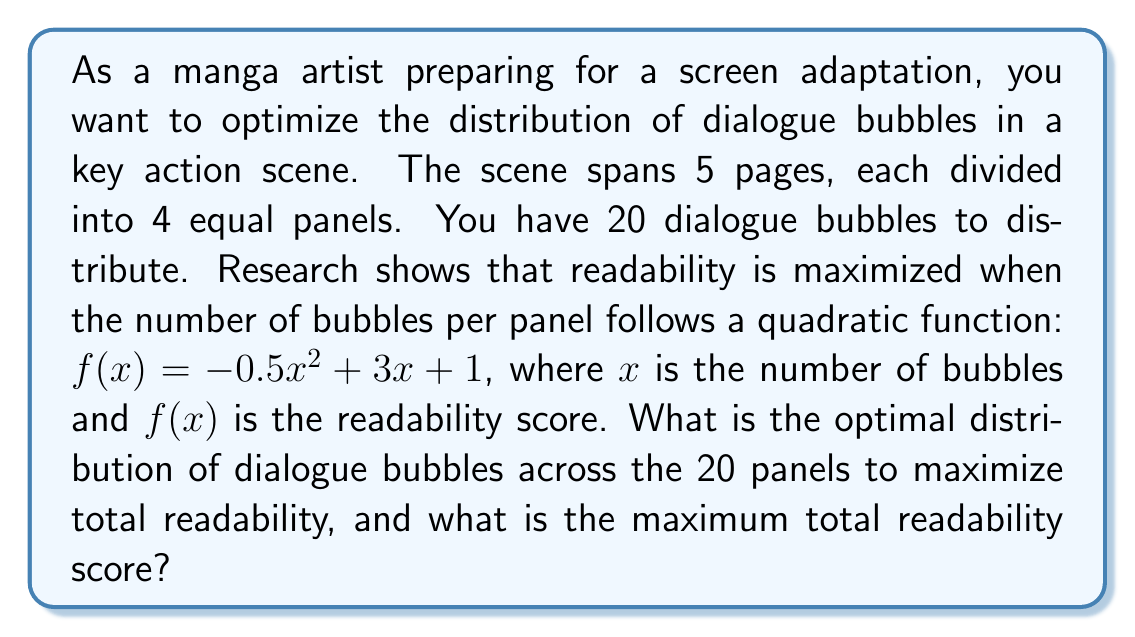Help me with this question. To solve this problem, we need to use integer programming techniques from operations research. Let's approach this step-by-step:

1) First, we need to set up our objective function. We want to maximize the total readability score across all panels:

   $\text{Maximize } \sum_{i=1}^{20} (-0.5x_i^2 + 3x_i + 1)$

   where $x_i$ is the number of bubbles in panel $i$.

2) Our constraints are:
   - The sum of all bubbles must equal 20: $\sum_{i=1}^{20} x_i = 20$
   - Each $x_i$ must be a non-negative integer

3) To find the optimal solution, we can use the method of Lagrange multipliers. However, due to the integer constraint, we need to round our results.

4) The Lagrangian function is:

   $L(x_1, ..., x_{20}, \lambda) = \sum_{i=1}^{20} (-0.5x_i^2 + 3x_i + 1) - \lambda(\sum_{i=1}^{20} x_i - 20)$

5) Taking partial derivatives and setting them to zero:

   $\frac{\partial L}{\partial x_i} = -x_i + 3 - \lambda = 0$ for all $i$
   $\frac{\partial L}{\partial \lambda} = \sum_{i=1}^{20} x_i - 20 = 0$

6) From the first equation: $x_i = 3 - \lambda$ for all $i$

7) Substituting into the second equation:
   $20(3 - \lambda) = 20$
   $60 - 20\lambda = 20$
   $\lambda = 2$

8) Therefore, the optimal continuous solution is $x_i = 1$ for all $i$

9) Since we need integer solutions and we have 20 bubbles to distribute among 20 panels, the optimal integer solution is indeed to place 1 bubble in each panel.

10) The total readability score is thus:
    $20 * (-0.5(1)^2 + 3(1) + 1) = 20 * 3.5 = 70$
Answer: The optimal distribution is 1 dialogue bubble per panel across all 20 panels. The maximum total readability score is 70. 